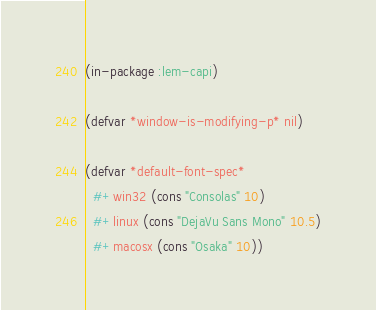Convert code to text. <code><loc_0><loc_0><loc_500><loc_500><_Lisp_>(in-package :lem-capi)

(defvar *window-is-modifying-p* nil)

(defvar *default-font-spec*
  #+win32 (cons "Consolas" 10)
  #+linux (cons "DejaVu Sans Mono" 10.5)
  #+macosx (cons "Osaka" 10))
</code> 